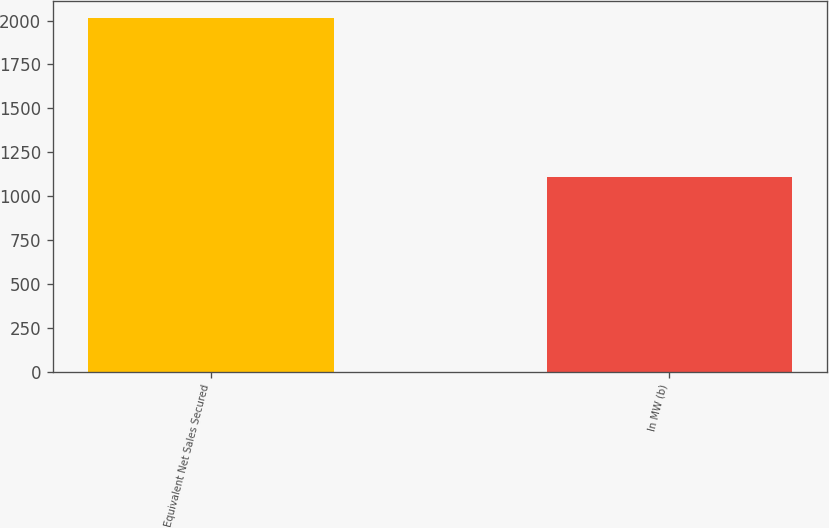<chart> <loc_0><loc_0><loc_500><loc_500><bar_chart><fcel>Equivalent Net Sales Secured<fcel>In MW (b)<nl><fcel>2012<fcel>1111<nl></chart> 